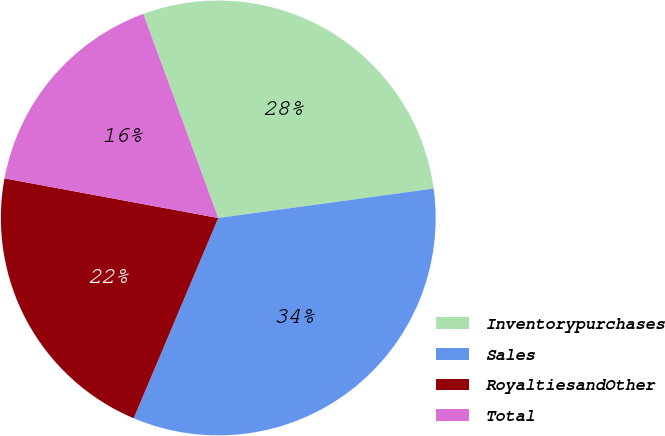<chart> <loc_0><loc_0><loc_500><loc_500><pie_chart><fcel>Inventorypurchases<fcel>Sales<fcel>RoyaltiesandOther<fcel>Total<nl><fcel>28.44%<fcel>33.52%<fcel>21.56%<fcel>16.48%<nl></chart> 